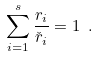Convert formula to latex. <formula><loc_0><loc_0><loc_500><loc_500>\sum _ { i = 1 } ^ { s } \frac { r _ { i } } { \check { r } _ { i } } = 1 \ .</formula> 